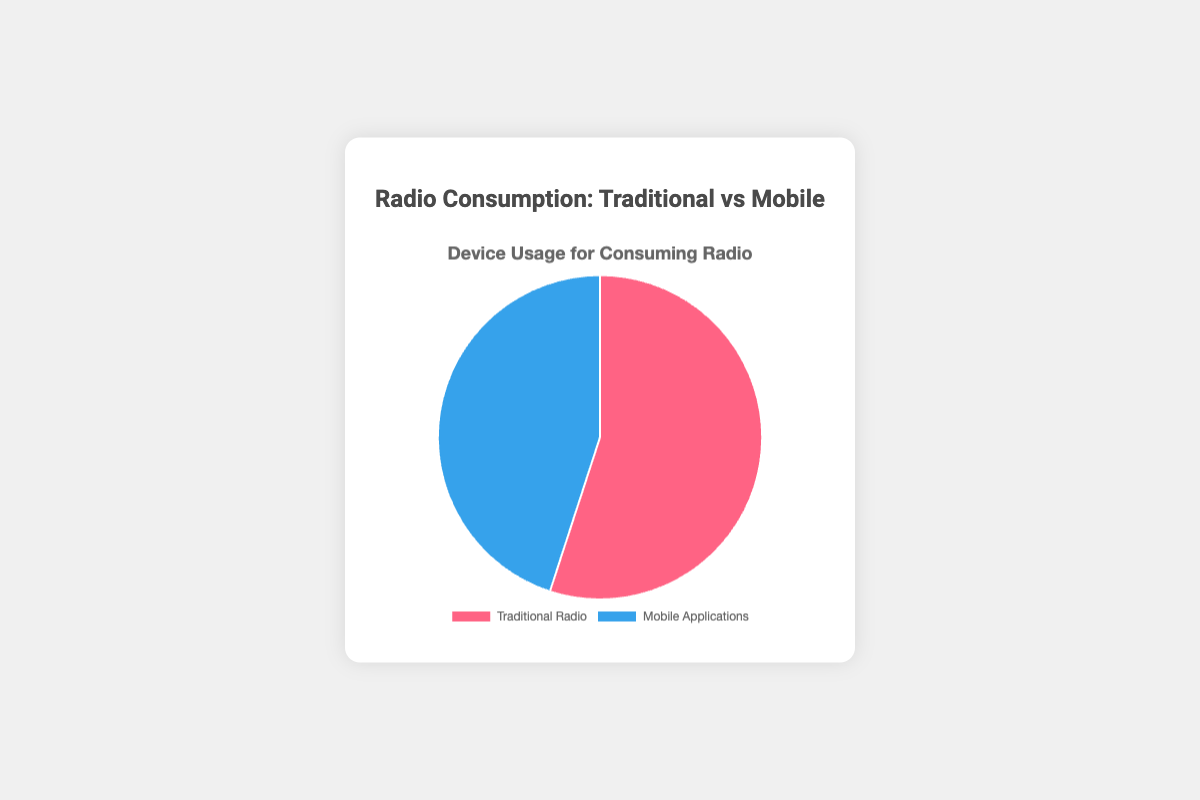What is the percentage of people who use Traditional Radio to consume radio? The Traditional Radio section of the pie chart shows a larger portion compared to Mobile Applications. The data label indicates 55%.
Answer: 55% What device is more popular for consuming radio? By comparing the two sections of the pie chart, Traditional Radio has a larger percentage (55%) than Mobile Applications (45%).
Answer: Traditional Radio What is the difference in percentage between Traditional Radio users and Mobile Application users? Subtract the percentage for Mobile Applications from the percentage for Traditional Radio: 55% - 45% = 10%.
Answer: 10% What percentage of people use Mobile Applications to consume radio? The Mobile Applications section of the pie chart is smaller than Traditional Radio. The data label indicates 45%.
Answer: 45% How do the percentages of Traditional Radio and Mobile Applications compare visually in terms of color? Traditional Radio is represented by a red color, while Mobile Applications is represented by a blue color.
Answer: Traditional Radio is red, Mobile Applications is blue What fraction of the total does Mobile Applications account for? Mobile Applications account for 45% of the total. Converting this to a fraction gives 45/100 = 9/20.
Answer: 9/20 Which segment in the pie chart occupies more space? Visually, the segment corresponding to Traditional Radio occupies more space in the pie chart than the segment for Mobile Applications.
Answer: Traditional Radio If the total percentage of radio consumption is split evenly, how much more is the Traditional Radio percentage than the expected 50%? The expected split for an even distribution is 50%. Traditional Radio is at 55%, so it is 55% - 50% = 5% more.
Answer: 5% What is the total percentage represented by both device usage options combined? Adding the percentages of Traditional Radio and Mobile Applications: 55% + 45% = 100%.
Answer: 100% If five more percentage points were allocated to Mobile Applications, what would both percentages be? Increase Mobile Applications from 45% to 50% and decrease Traditional Radio from 55% to 50% to maintain the total of 100%.
Answer: Both would be 50% 